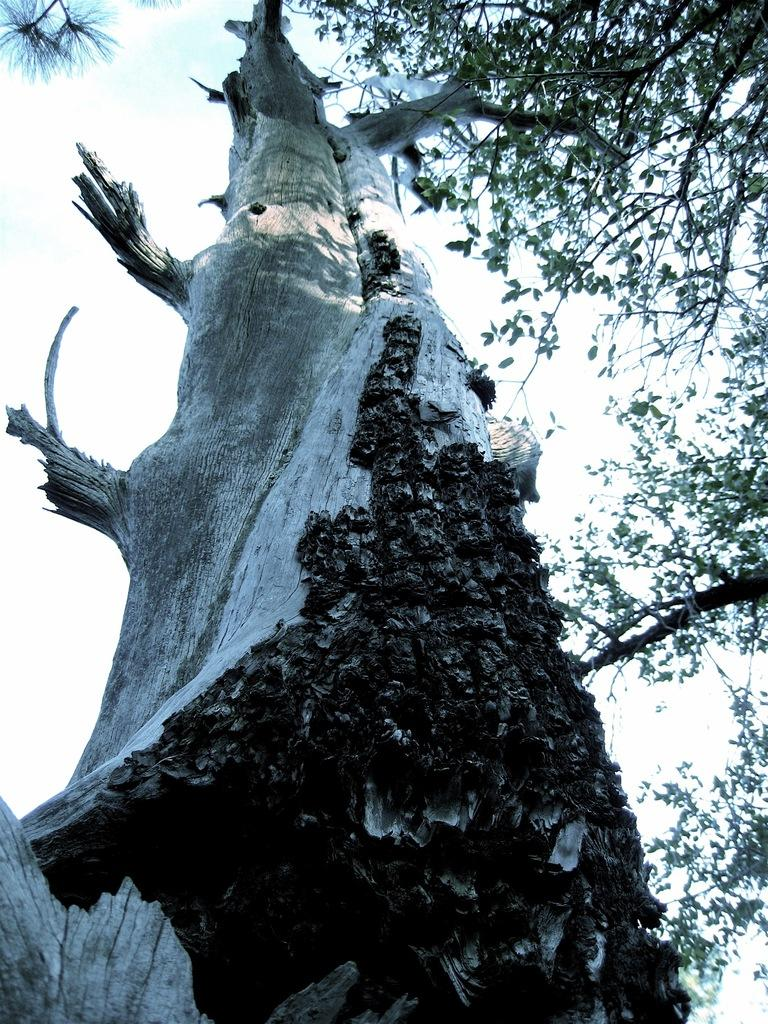What type of vegetation can be seen in the image? There are trees in the image. What part of the trees is visible in the image? There are branches in the image. What can be seen in the background of the image? The sky is visible in the background of the image. What type of steel structure can be seen in the image? There is no steel structure present in the image; it features trees and branches. What type of sand formation can be seen in the image? There is no sand formation present in the image; it features trees and branches. 